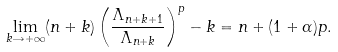<formula> <loc_0><loc_0><loc_500><loc_500>\lim _ { k \rightarrow + \infty } ( n + k ) \left ( \frac { \Lambda _ { n + k + 1 } } { \Lambda _ { n + k } } \right ) ^ { p } - k = n + ( 1 + \alpha ) p .</formula> 